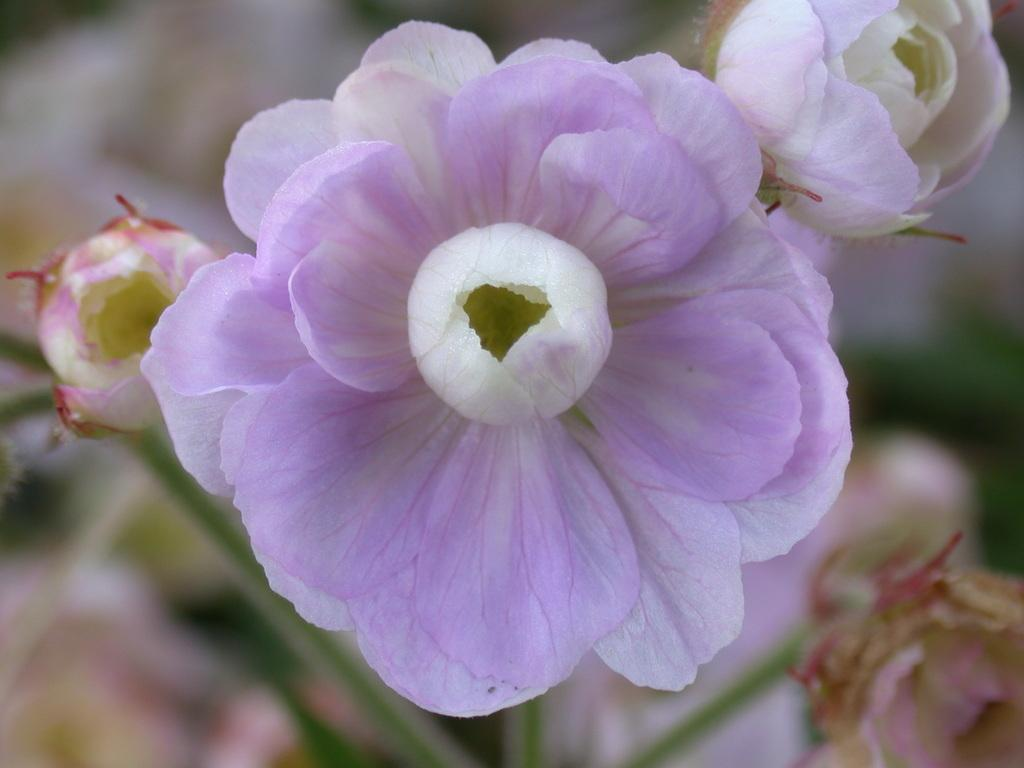What type of plants can be seen in the image? There are flowers in the image. Can you describe the background of the image? The background of the image is blurry. What type of jam is being spread on the scarecrow's trousers in the image? There is no jam or scarecrow present in the image; it only features flowers and a blurry background. 